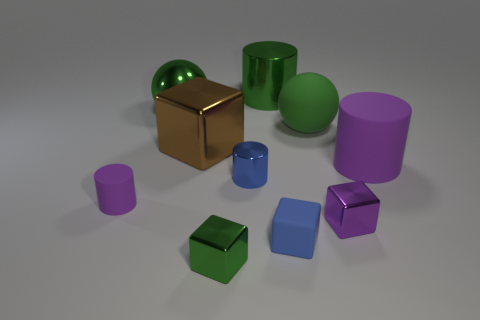Are there fewer purple shiny blocks than cyan blocks?
Your response must be concise. No. Do the green thing in front of the brown metal thing and the matte object on the left side of the small blue rubber object have the same shape?
Offer a terse response. No. The tiny matte cylinder is what color?
Give a very brief answer. Purple. What number of metallic objects are large brown objects or yellow things?
Provide a succinct answer. 1. The tiny matte thing that is the same shape as the big brown shiny object is what color?
Offer a terse response. Blue. Are any red rubber things visible?
Your answer should be very brief. No. Are the tiny purple thing that is behind the purple cube and the cube behind the tiny purple metal thing made of the same material?
Give a very brief answer. No. There is a rubber thing that is the same color as the big metallic cylinder; what is its shape?
Provide a short and direct response. Sphere. How many things are either big objects to the left of the tiny green block or tiny rubber objects that are behind the small purple metallic block?
Offer a very short reply. 3. Is the color of the tiny rubber thing to the right of the small green metal cube the same as the shiny cylinder that is in front of the green matte sphere?
Your response must be concise. Yes. 